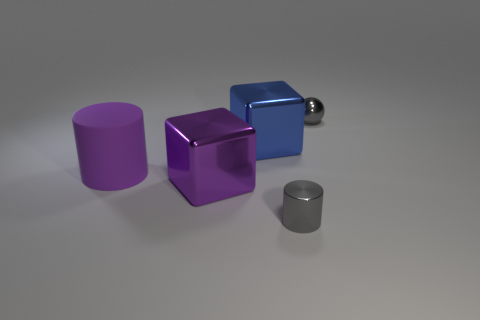Add 2 large matte things. How many objects exist? 7 Subtract all balls. How many objects are left? 4 Add 4 big metal things. How many big metal things exist? 6 Subtract 0 blue cylinders. How many objects are left? 5 Subtract all purple rubber cylinders. Subtract all blocks. How many objects are left? 2 Add 3 small spheres. How many small spheres are left? 4 